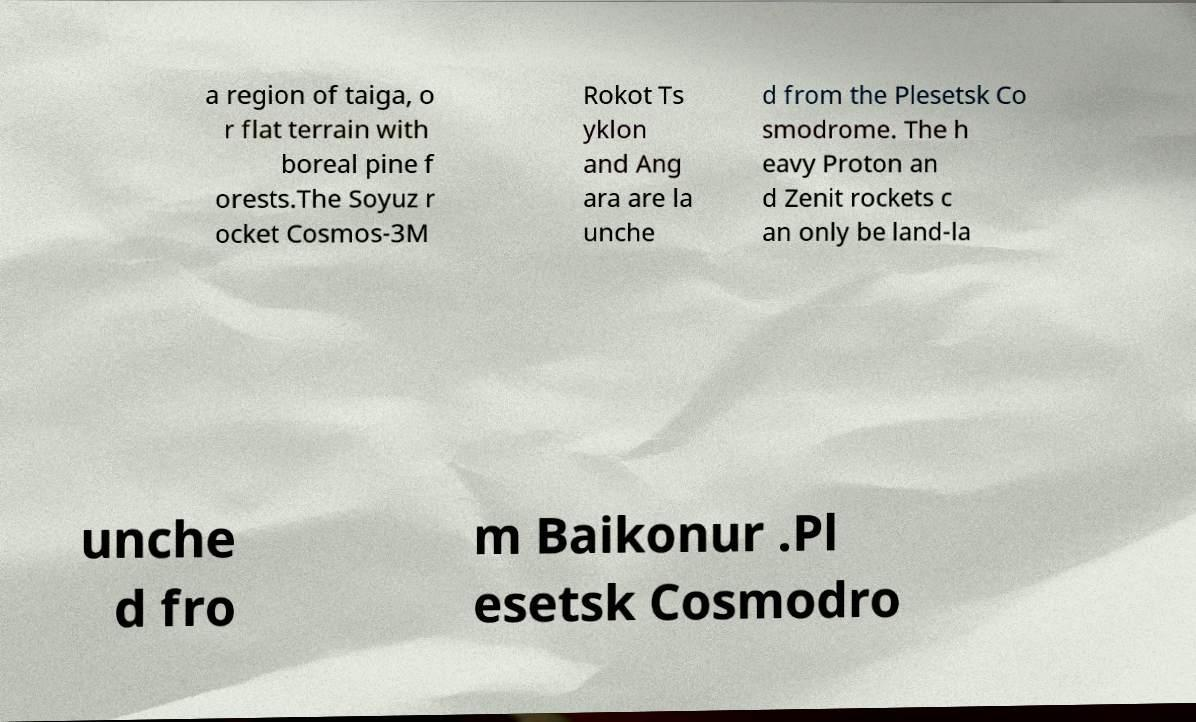There's text embedded in this image that I need extracted. Can you transcribe it verbatim? a region of taiga, o r flat terrain with boreal pine f orests.The Soyuz r ocket Cosmos-3M Rokot Ts yklon and Ang ara are la unche d from the Plesetsk Co smodrome. The h eavy Proton an d Zenit rockets c an only be land-la unche d fro m Baikonur .Pl esetsk Cosmodro 